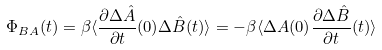Convert formula to latex. <formula><loc_0><loc_0><loc_500><loc_500>\Phi _ { B A } ( t ) = \beta \langle \frac { \partial \Delta \hat { A } } { \partial t } ( 0 ) \Delta \hat { B } ( t ) \rangle = - \beta \langle \Delta A ( 0 ) \frac { \partial \Delta \hat { B } } { \partial t } ( t ) \rangle</formula> 